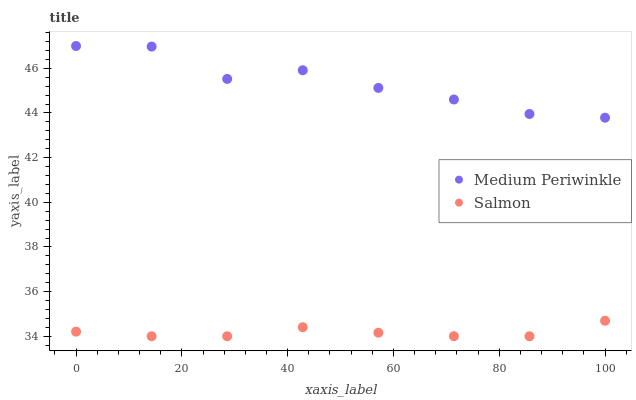Does Salmon have the minimum area under the curve?
Answer yes or no. Yes. Does Medium Periwinkle have the maximum area under the curve?
Answer yes or no. Yes. Does Medium Periwinkle have the minimum area under the curve?
Answer yes or no. No. Is Salmon the smoothest?
Answer yes or no. Yes. Is Medium Periwinkle the roughest?
Answer yes or no. Yes. Is Medium Periwinkle the smoothest?
Answer yes or no. No. Does Salmon have the lowest value?
Answer yes or no. Yes. Does Medium Periwinkle have the lowest value?
Answer yes or no. No. Does Medium Periwinkle have the highest value?
Answer yes or no. Yes. Is Salmon less than Medium Periwinkle?
Answer yes or no. Yes. Is Medium Periwinkle greater than Salmon?
Answer yes or no. Yes. Does Salmon intersect Medium Periwinkle?
Answer yes or no. No. 